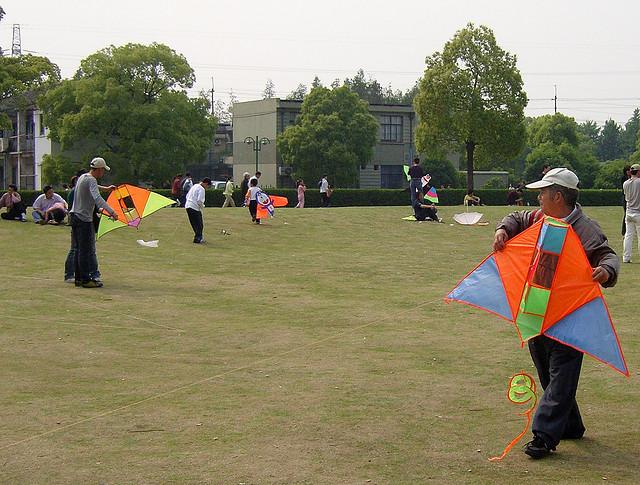Was the grass in this photo recently mowed?
Answer briefly. Yes. How many people are holding a kite in this scene?
Answer briefly. 4. Is the kite flying?
Give a very brief answer. No. Are they on the street?
Write a very short answer. No. What color is the sky?
Be succinct. Gray. 